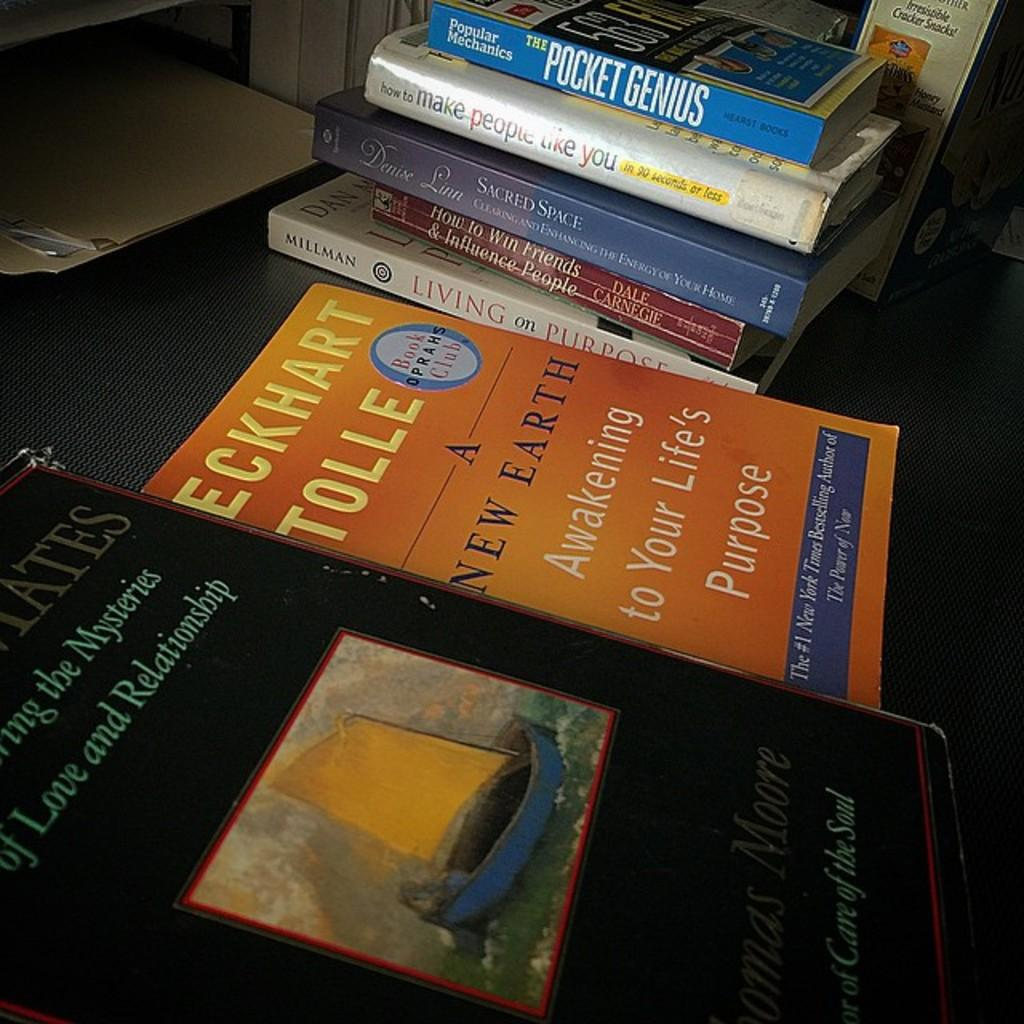<image>
Render a clear and concise summary of the photo. Blue book titled "Pocket Genius" on top of a stack of other books. 